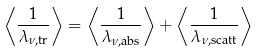<formula> <loc_0><loc_0><loc_500><loc_500>\left \langle \frac { 1 } { \lambda _ { \nu , \text {tr} } } \right \rangle = \left \langle \frac { 1 } { \lambda _ { \nu , \text {abs} } } \right \rangle + \left \langle \frac { 1 } { \lambda _ { \nu , \text {scatt} } } \right \rangle</formula> 